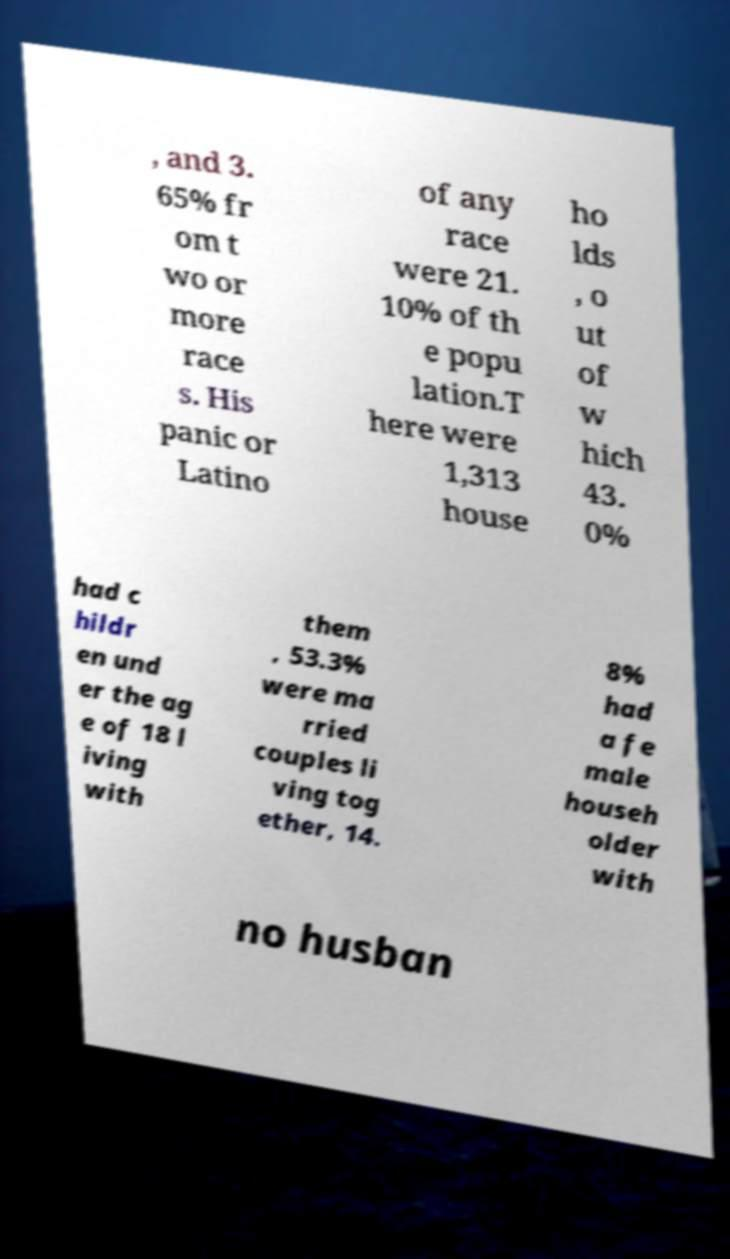Please read and relay the text visible in this image. What does it say? , and 3. 65% fr om t wo or more race s. His panic or Latino of any race were 21. 10% of th e popu lation.T here were 1,313 house ho lds , o ut of w hich 43. 0% had c hildr en und er the ag e of 18 l iving with them , 53.3% were ma rried couples li ving tog ether, 14. 8% had a fe male househ older with no husban 